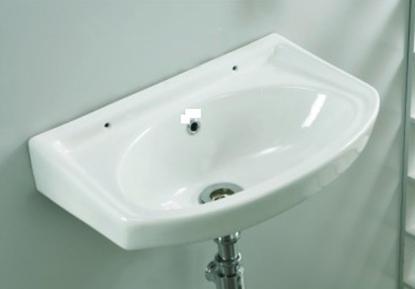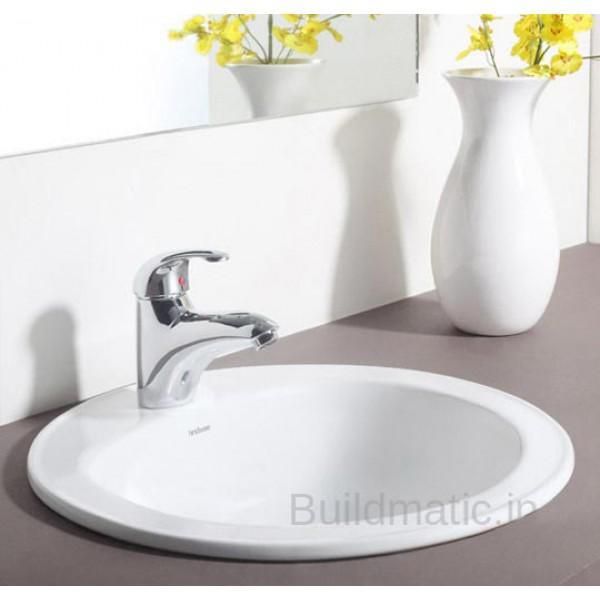The first image is the image on the left, the second image is the image on the right. For the images displayed, is the sentence "In one of the images, there is a white vase with yellow flowers in it" factually correct? Answer yes or no. Yes. 